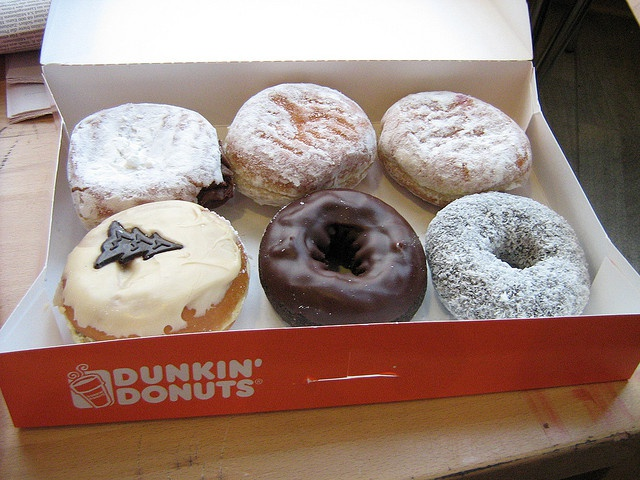Describe the objects in this image and their specific colors. I can see dining table in lavender, black, maroon, brown, and gray tones, donut in lavender, ivory, darkgray, and tan tones, donut in lavender, black, and gray tones, donut in lavender, lightgray, darkgray, and gray tones, and cake in lavender, lightgray, darkgray, black, and gray tones in this image. 